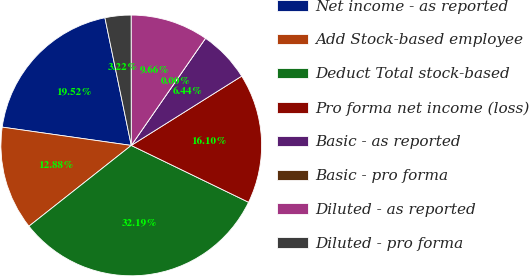Convert chart to OTSL. <chart><loc_0><loc_0><loc_500><loc_500><pie_chart><fcel>Net income - as reported<fcel>Add Stock-based employee<fcel>Deduct Total stock-based<fcel>Pro forma net income (loss)<fcel>Basic - as reported<fcel>Basic - pro forma<fcel>Diluted - as reported<fcel>Diluted - pro forma<nl><fcel>19.52%<fcel>12.88%<fcel>32.19%<fcel>16.1%<fcel>6.44%<fcel>0.0%<fcel>9.66%<fcel>3.22%<nl></chart> 